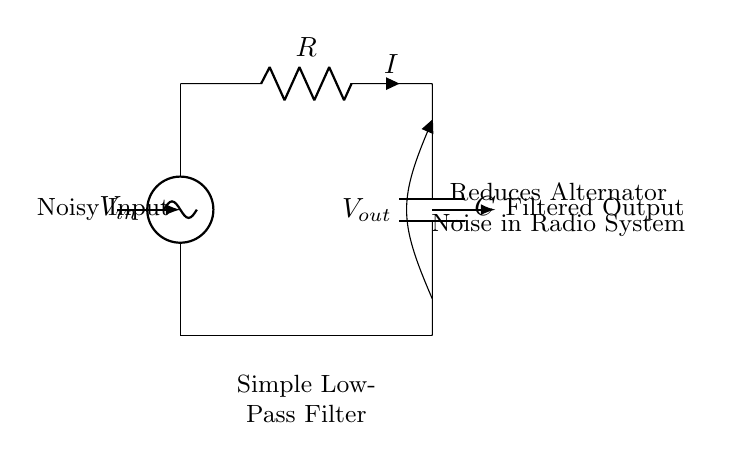What is the input voltage source labeled as? The input voltage source is labeled as V in, which indicates the noisy voltage entering the circuit.
Answer: V in What type of filter is shown in the circuit? The circuit is labeled as a Simple Low-Pass Filter, which is designed to allow low-frequency signals to pass while attenuating high-frequency noise.
Answer: Low-Pass Filter What components are used in this circuit? The circuit contains a resistor and a capacitor, which are the two essential components used to create the low-pass filter effect.
Answer: Resistor and Capacitor What does V out represent? V out is labeled as the output voltage, which is the filtered signal after passing through the low-pass filter.
Answer: Filtered Output How does the current flow in this circuit? The current flows from the input voltage source through the resistor, then into the capacitor before reaching the output; it follows the path from V in to V out.
Answer: From V in to V out What happens to the alternator noise in this circuit? The alternator noise is reduced when the signal passes through the low-pass filter, which removes high-frequency components while allowing low frequencies to pass.
Answer: Reduced What is the purpose of the capacitor in this circuit? The capacitor stores and releases energy, allowing it to block high-frequency noise while passing lower frequencies to the output.
Answer: Block high-frequency noise 